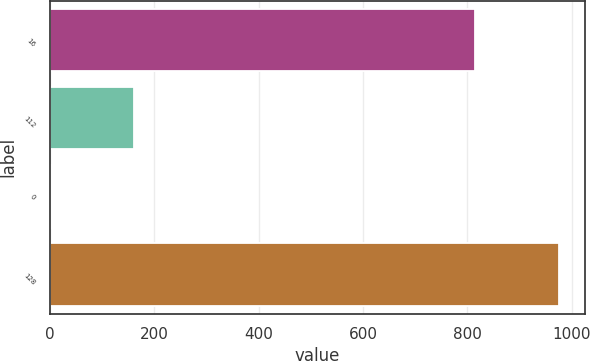Convert chart. <chart><loc_0><loc_0><loc_500><loc_500><bar_chart><fcel>16<fcel>112<fcel>0<fcel>128<nl><fcel>815<fcel>161<fcel>1.71<fcel>976<nl></chart> 